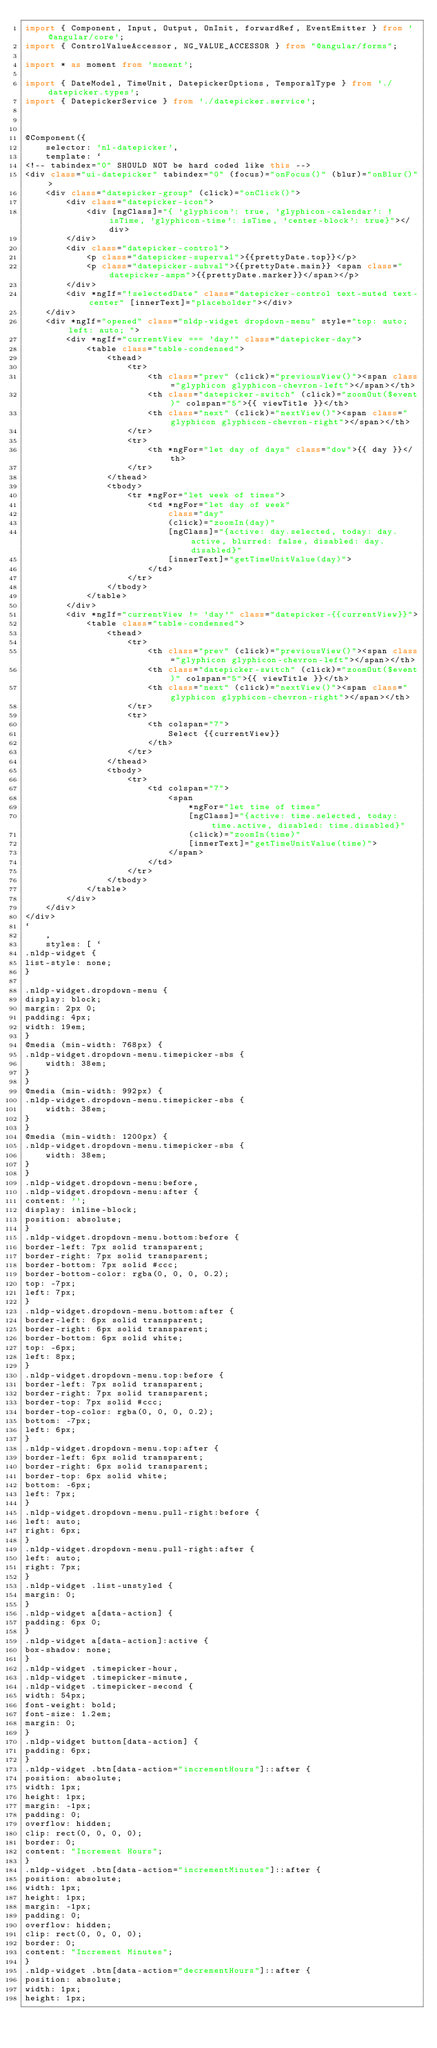<code> <loc_0><loc_0><loc_500><loc_500><_TypeScript_>import { Component, Input, Output, OnInit, forwardRef, EventEmitter } from '@angular/core';
import { ControlValueAccessor, NG_VALUE_ACCESSOR } from "@angular/forms";

import * as moment from 'moment';

import { DateModel, TimeUnit, DatepickerOptions, TemporalType } from './datepicker.types';
import { DatepickerService } from './datepicker.service';



@Component({
    selector: 'nl-datepicker',
    template: `
<!-- tabindex="0" SHOULD NOT be hard coded like this -->
<div class="ui-datepicker" tabindex="0" (focus)="onFocus()" (blur)="onBlur()">
    <div class="datepicker-group" (click)="onClick()">
        <div class="datepicker-icon">
            <div [ngClass]="{ 'glyphicon': true, 'glyphicon-calendar': !isTime, 'glyphicon-time': isTime, 'center-block': true}"></div>
        </div>
        <div class="datepicker-control">
            <p class="datepicker-superval">{{prettyDate.top}}</p>
            <p class="datepicker-subval">{{prettyDate.main}} <span class="datepicker-ampm">{{prettyDate.marker}}</span></p>
        </div>
        <div *ngIf="!selectedDate" class="datepicker-control text-muted text-center" [innerText]="placeholder"></div>
    </div>
    <div *ngIf="opened" class="nldp-widget dropdown-menu" style="top: auto; left: auto; ">
        <div *ngIf="currentView === 'day'" class="datepicker-day">
            <table class="table-condensed">
                <thead>
                    <tr>
                        <th class="prev" (click)="previousView()"><span class="glyphicon glyphicon-chevron-left"></span></th>
                        <th class="datepicker-switch" (click)="zoomOut($event)" colspan="5">{{ viewTitle }}</th>
                        <th class="next" (click)="nextView()"><span class="glyphicon glyphicon-chevron-right"></span></th>
                    </tr>
                    <tr>
                        <th *ngFor="let day of days" class="dow">{{ day }}</th>
                    </tr>
                </thead>
                <tbody>
                    <tr *ngFor="let week of times">
                        <td *ngFor="let day of week"
                            class="day"
                            (click)="zoomIn(day)" 
                            [ngClass]="{active: day.selected, today: day.active, blurred: false, disabled: day.disabled}"
                            [innerText]="getTimeUnitValue(day)">
                        </td>
                    </tr>
                </tbody>
            </table>
        </div>
        <div *ngIf="currentView != 'day'" class="datepicker-{{currentView}}">
            <table class="table-condensed">
                <thead>
                    <tr>
                        <th class="prev" (click)="previousView()"><span class="glyphicon glyphicon-chevron-left"></span></th>
                        <th class="datepicker-switch" (click)="zoomOut($event)" colspan="5">{{ viewTitle }}</th>
                        <th class="next" (click)="nextView()"><span class="glyphicon glyphicon-chevron-right"></span></th>
                    </tr>
                    <tr>
                        <th colspan="7">
                            Select {{currentView}}
                        </th>
                    </tr>                        
                </thead>
                <tbody>
                    <tr>
                        <td colspan="7">
                            <span 
                                *ngFor="let time of times"
                                [ngClass]="{active: time.selected, today: time.active, disabled: time.disabled}"
                                (click)="zoomIn(time)"
                                [innerText]="getTimeUnitValue(time)">
                            </span>
                        </td>
                    </tr>
                </tbody>
            </table>
        </div>
    </div>
</div>
`
    ,
    styles: [ `
.nldp-widget {
list-style: none;
}

.nldp-widget.dropdown-menu {
display: block;
margin: 2px 0;
padding: 4px;
width: 19em;
}
@media (min-width: 768px) {
.nldp-widget.dropdown-menu.timepicker-sbs {
    width: 38em;
}
}
@media (min-width: 992px) {
.nldp-widget.dropdown-menu.timepicker-sbs {
    width: 38em;
}
}
@media (min-width: 1200px) {
.nldp-widget.dropdown-menu.timepicker-sbs {
    width: 38em;
}
}
.nldp-widget.dropdown-menu:before,
.nldp-widget.dropdown-menu:after {
content: '';
display: inline-block;
position: absolute;
}
.nldp-widget.dropdown-menu.bottom:before {
border-left: 7px solid transparent;
border-right: 7px solid transparent;
border-bottom: 7px solid #ccc;
border-bottom-color: rgba(0, 0, 0, 0.2);
top: -7px;
left: 7px;
}
.nldp-widget.dropdown-menu.bottom:after {
border-left: 6px solid transparent;
border-right: 6px solid transparent;
border-bottom: 6px solid white;
top: -6px;
left: 8px;
}
.nldp-widget.dropdown-menu.top:before {
border-left: 7px solid transparent;
border-right: 7px solid transparent;
border-top: 7px solid #ccc;
border-top-color: rgba(0, 0, 0, 0.2);
bottom: -7px;
left: 6px;
}
.nldp-widget.dropdown-menu.top:after {
border-left: 6px solid transparent;
border-right: 6px solid transparent;
border-top: 6px solid white;
bottom: -6px;
left: 7px;
}
.nldp-widget.dropdown-menu.pull-right:before {
left: auto;
right: 6px;
}
.nldp-widget.dropdown-menu.pull-right:after {
left: auto;
right: 7px;
}
.nldp-widget .list-unstyled {
margin: 0;
}
.nldp-widget a[data-action] {
padding: 6px 0;
}
.nldp-widget a[data-action]:active {
box-shadow: none;
}
.nldp-widget .timepicker-hour,
.nldp-widget .timepicker-minute,
.nldp-widget .timepicker-second {
width: 54px;
font-weight: bold;
font-size: 1.2em;
margin: 0;
}
.nldp-widget button[data-action] {
padding: 6px;
}
.nldp-widget .btn[data-action="incrementHours"]::after {
position: absolute;
width: 1px;
height: 1px;
margin: -1px;
padding: 0;
overflow: hidden;
clip: rect(0, 0, 0, 0);
border: 0;
content: "Increment Hours";
}
.nldp-widget .btn[data-action="incrementMinutes"]::after {
position: absolute;
width: 1px;
height: 1px;
margin: -1px;
padding: 0;
overflow: hidden;
clip: rect(0, 0, 0, 0);
border: 0;
content: "Increment Minutes";
}
.nldp-widget .btn[data-action="decrementHours"]::after {
position: absolute;
width: 1px;
height: 1px;</code> 